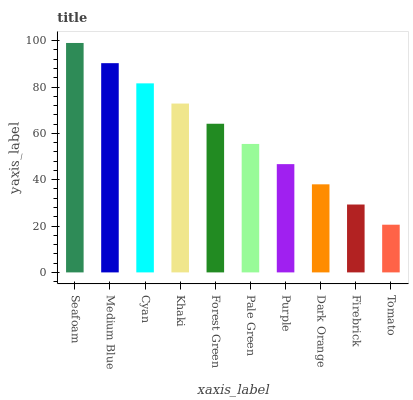Is Medium Blue the minimum?
Answer yes or no. No. Is Medium Blue the maximum?
Answer yes or no. No. Is Seafoam greater than Medium Blue?
Answer yes or no. Yes. Is Medium Blue less than Seafoam?
Answer yes or no. Yes. Is Medium Blue greater than Seafoam?
Answer yes or no. No. Is Seafoam less than Medium Blue?
Answer yes or no. No. Is Forest Green the high median?
Answer yes or no. Yes. Is Pale Green the low median?
Answer yes or no. Yes. Is Seafoam the high median?
Answer yes or no. No. Is Cyan the low median?
Answer yes or no. No. 